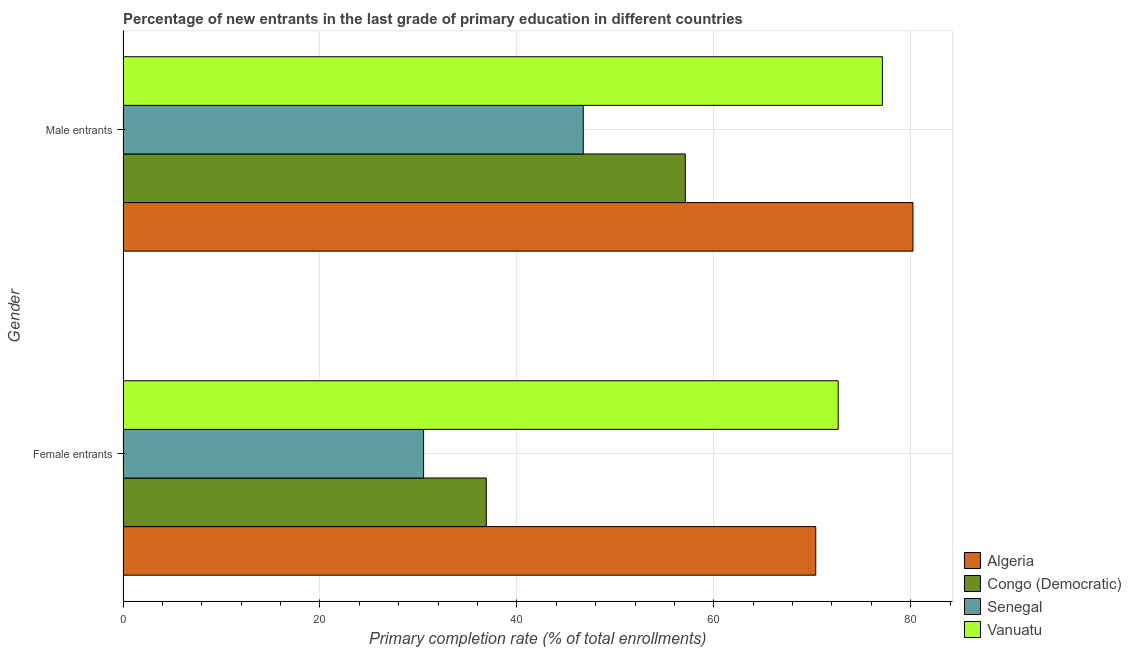How many different coloured bars are there?
Keep it short and to the point. 4. How many groups of bars are there?
Give a very brief answer. 2. Are the number of bars per tick equal to the number of legend labels?
Keep it short and to the point. Yes. Are the number of bars on each tick of the Y-axis equal?
Offer a terse response. Yes. How many bars are there on the 2nd tick from the top?
Ensure brevity in your answer.  4. How many bars are there on the 1st tick from the bottom?
Give a very brief answer. 4. What is the label of the 2nd group of bars from the top?
Keep it short and to the point. Female entrants. What is the primary completion rate of female entrants in Congo (Democratic)?
Ensure brevity in your answer.  36.89. Across all countries, what is the maximum primary completion rate of female entrants?
Make the answer very short. 72.64. Across all countries, what is the minimum primary completion rate of male entrants?
Keep it short and to the point. 46.74. In which country was the primary completion rate of male entrants maximum?
Keep it short and to the point. Algeria. In which country was the primary completion rate of female entrants minimum?
Your answer should be compact. Senegal. What is the total primary completion rate of female entrants in the graph?
Your answer should be very brief. 210.42. What is the difference between the primary completion rate of male entrants in Vanuatu and that in Algeria?
Your response must be concise. -3.11. What is the difference between the primary completion rate of female entrants in Congo (Democratic) and the primary completion rate of male entrants in Senegal?
Give a very brief answer. -9.85. What is the average primary completion rate of male entrants per country?
Ensure brevity in your answer.  65.3. What is the difference between the primary completion rate of male entrants and primary completion rate of female entrants in Senegal?
Make the answer very short. 16.21. What is the ratio of the primary completion rate of female entrants in Algeria to that in Vanuatu?
Your answer should be compact. 0.97. In how many countries, is the primary completion rate of female entrants greater than the average primary completion rate of female entrants taken over all countries?
Ensure brevity in your answer.  2. What does the 2nd bar from the top in Female entrants represents?
Give a very brief answer. Senegal. What does the 3rd bar from the bottom in Male entrants represents?
Your response must be concise. Senegal. Are all the bars in the graph horizontal?
Keep it short and to the point. Yes. What is the difference between two consecutive major ticks on the X-axis?
Offer a terse response. 20. Does the graph contain grids?
Provide a short and direct response. Yes. How many legend labels are there?
Your answer should be very brief. 4. What is the title of the graph?
Make the answer very short. Percentage of new entrants in the last grade of primary education in different countries. What is the label or title of the X-axis?
Provide a succinct answer. Primary completion rate (% of total enrollments). What is the Primary completion rate (% of total enrollments) of Algeria in Female entrants?
Offer a very short reply. 70.35. What is the Primary completion rate (% of total enrollments) in Congo (Democratic) in Female entrants?
Your answer should be compact. 36.89. What is the Primary completion rate (% of total enrollments) in Senegal in Female entrants?
Your response must be concise. 30.53. What is the Primary completion rate (% of total enrollments) in Vanuatu in Female entrants?
Your response must be concise. 72.64. What is the Primary completion rate (% of total enrollments) in Algeria in Male entrants?
Offer a very short reply. 80.23. What is the Primary completion rate (% of total enrollments) in Congo (Democratic) in Male entrants?
Give a very brief answer. 57.11. What is the Primary completion rate (% of total enrollments) in Senegal in Male entrants?
Your answer should be compact. 46.74. What is the Primary completion rate (% of total enrollments) of Vanuatu in Male entrants?
Provide a short and direct response. 77.12. Across all Gender, what is the maximum Primary completion rate (% of total enrollments) of Algeria?
Make the answer very short. 80.23. Across all Gender, what is the maximum Primary completion rate (% of total enrollments) of Congo (Democratic)?
Offer a terse response. 57.11. Across all Gender, what is the maximum Primary completion rate (% of total enrollments) of Senegal?
Give a very brief answer. 46.74. Across all Gender, what is the maximum Primary completion rate (% of total enrollments) of Vanuatu?
Offer a terse response. 77.12. Across all Gender, what is the minimum Primary completion rate (% of total enrollments) of Algeria?
Make the answer very short. 70.35. Across all Gender, what is the minimum Primary completion rate (% of total enrollments) of Congo (Democratic)?
Ensure brevity in your answer.  36.89. Across all Gender, what is the minimum Primary completion rate (% of total enrollments) of Senegal?
Your answer should be compact. 30.53. Across all Gender, what is the minimum Primary completion rate (% of total enrollments) in Vanuatu?
Provide a succinct answer. 72.64. What is the total Primary completion rate (% of total enrollments) in Algeria in the graph?
Provide a succinct answer. 150.58. What is the total Primary completion rate (% of total enrollments) of Congo (Democratic) in the graph?
Your answer should be compact. 94. What is the total Primary completion rate (% of total enrollments) in Senegal in the graph?
Your answer should be compact. 77.27. What is the total Primary completion rate (% of total enrollments) of Vanuatu in the graph?
Keep it short and to the point. 149.76. What is the difference between the Primary completion rate (% of total enrollments) of Algeria in Female entrants and that in Male entrants?
Your response must be concise. -9.87. What is the difference between the Primary completion rate (% of total enrollments) in Congo (Democratic) in Female entrants and that in Male entrants?
Give a very brief answer. -20.21. What is the difference between the Primary completion rate (% of total enrollments) of Senegal in Female entrants and that in Male entrants?
Provide a short and direct response. -16.21. What is the difference between the Primary completion rate (% of total enrollments) in Vanuatu in Female entrants and that in Male entrants?
Provide a succinct answer. -4.49. What is the difference between the Primary completion rate (% of total enrollments) of Algeria in Female entrants and the Primary completion rate (% of total enrollments) of Congo (Democratic) in Male entrants?
Keep it short and to the point. 13.25. What is the difference between the Primary completion rate (% of total enrollments) in Algeria in Female entrants and the Primary completion rate (% of total enrollments) in Senegal in Male entrants?
Provide a short and direct response. 23.61. What is the difference between the Primary completion rate (% of total enrollments) in Algeria in Female entrants and the Primary completion rate (% of total enrollments) in Vanuatu in Male entrants?
Your answer should be compact. -6.77. What is the difference between the Primary completion rate (% of total enrollments) of Congo (Democratic) in Female entrants and the Primary completion rate (% of total enrollments) of Senegal in Male entrants?
Your answer should be very brief. -9.85. What is the difference between the Primary completion rate (% of total enrollments) in Congo (Democratic) in Female entrants and the Primary completion rate (% of total enrollments) in Vanuatu in Male entrants?
Keep it short and to the point. -40.23. What is the difference between the Primary completion rate (% of total enrollments) of Senegal in Female entrants and the Primary completion rate (% of total enrollments) of Vanuatu in Male entrants?
Ensure brevity in your answer.  -46.59. What is the average Primary completion rate (% of total enrollments) of Algeria per Gender?
Your answer should be compact. 75.29. What is the average Primary completion rate (% of total enrollments) of Congo (Democratic) per Gender?
Give a very brief answer. 47. What is the average Primary completion rate (% of total enrollments) of Senegal per Gender?
Your response must be concise. 38.64. What is the average Primary completion rate (% of total enrollments) of Vanuatu per Gender?
Provide a succinct answer. 74.88. What is the difference between the Primary completion rate (% of total enrollments) in Algeria and Primary completion rate (% of total enrollments) in Congo (Democratic) in Female entrants?
Your response must be concise. 33.46. What is the difference between the Primary completion rate (% of total enrollments) of Algeria and Primary completion rate (% of total enrollments) of Senegal in Female entrants?
Ensure brevity in your answer.  39.82. What is the difference between the Primary completion rate (% of total enrollments) of Algeria and Primary completion rate (% of total enrollments) of Vanuatu in Female entrants?
Make the answer very short. -2.28. What is the difference between the Primary completion rate (% of total enrollments) of Congo (Democratic) and Primary completion rate (% of total enrollments) of Senegal in Female entrants?
Ensure brevity in your answer.  6.36. What is the difference between the Primary completion rate (% of total enrollments) of Congo (Democratic) and Primary completion rate (% of total enrollments) of Vanuatu in Female entrants?
Keep it short and to the point. -35.74. What is the difference between the Primary completion rate (% of total enrollments) in Senegal and Primary completion rate (% of total enrollments) in Vanuatu in Female entrants?
Make the answer very short. -42.11. What is the difference between the Primary completion rate (% of total enrollments) in Algeria and Primary completion rate (% of total enrollments) in Congo (Democratic) in Male entrants?
Offer a very short reply. 23.12. What is the difference between the Primary completion rate (% of total enrollments) in Algeria and Primary completion rate (% of total enrollments) in Senegal in Male entrants?
Your response must be concise. 33.48. What is the difference between the Primary completion rate (% of total enrollments) in Algeria and Primary completion rate (% of total enrollments) in Vanuatu in Male entrants?
Make the answer very short. 3.11. What is the difference between the Primary completion rate (% of total enrollments) of Congo (Democratic) and Primary completion rate (% of total enrollments) of Senegal in Male entrants?
Provide a short and direct response. 10.36. What is the difference between the Primary completion rate (% of total enrollments) in Congo (Democratic) and Primary completion rate (% of total enrollments) in Vanuatu in Male entrants?
Offer a terse response. -20.01. What is the difference between the Primary completion rate (% of total enrollments) of Senegal and Primary completion rate (% of total enrollments) of Vanuatu in Male entrants?
Give a very brief answer. -30.38. What is the ratio of the Primary completion rate (% of total enrollments) of Algeria in Female entrants to that in Male entrants?
Ensure brevity in your answer.  0.88. What is the ratio of the Primary completion rate (% of total enrollments) of Congo (Democratic) in Female entrants to that in Male entrants?
Offer a terse response. 0.65. What is the ratio of the Primary completion rate (% of total enrollments) in Senegal in Female entrants to that in Male entrants?
Your response must be concise. 0.65. What is the ratio of the Primary completion rate (% of total enrollments) in Vanuatu in Female entrants to that in Male entrants?
Offer a very short reply. 0.94. What is the difference between the highest and the second highest Primary completion rate (% of total enrollments) in Algeria?
Your answer should be compact. 9.87. What is the difference between the highest and the second highest Primary completion rate (% of total enrollments) of Congo (Democratic)?
Your response must be concise. 20.21. What is the difference between the highest and the second highest Primary completion rate (% of total enrollments) of Senegal?
Offer a very short reply. 16.21. What is the difference between the highest and the second highest Primary completion rate (% of total enrollments) in Vanuatu?
Provide a succinct answer. 4.49. What is the difference between the highest and the lowest Primary completion rate (% of total enrollments) of Algeria?
Offer a very short reply. 9.87. What is the difference between the highest and the lowest Primary completion rate (% of total enrollments) of Congo (Democratic)?
Your response must be concise. 20.21. What is the difference between the highest and the lowest Primary completion rate (% of total enrollments) in Senegal?
Your answer should be very brief. 16.21. What is the difference between the highest and the lowest Primary completion rate (% of total enrollments) of Vanuatu?
Your response must be concise. 4.49. 